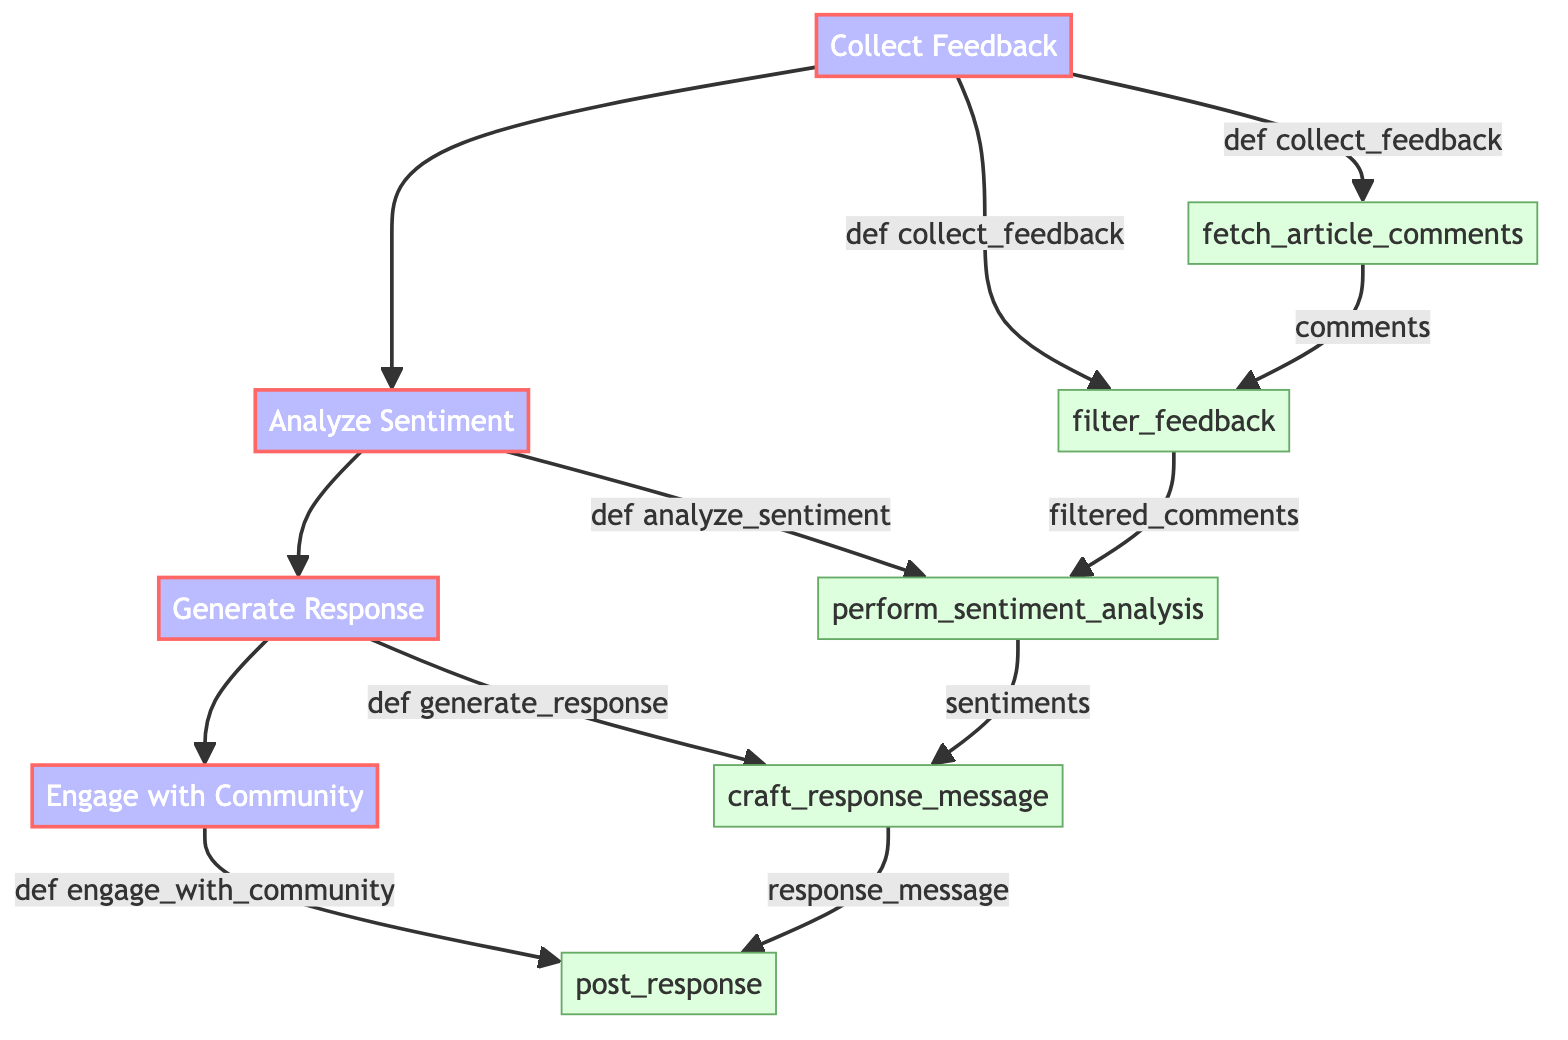What is the first step in the feedback handling process? The first step in the flowchart is "Collect Feedback," which initiates the feedback handling process for business-related news.
Answer: Collect Feedback How many main components are there in the flowchart? The flowchart has four main components: Collect Feedback, Analyze Sentiment, Generate Response, and Engage with Community.
Answer: Four What is the method associated with "Analyze Sentiment"? The method associated with "Analyze Sentiment" is "def analyze_sentiment(filtered_comments):" which initializes the sentiment analysis process mentioned in the diagram.
Answer: def analyze_sentiment(filtered_comments): Which sub-element follows "filter_feedback"? The sub-element that follows "filter_feedback" is "perform_sentiment_analysis," which further processes the filtered feedback.
Answer: perform_sentiment_analysis What action is taken after generating a response? After generating a response, the action taken is to "Engage with Community," which includes posting the response message to the community.
Answer: Engage with Community How does "fetch_article_comments" relate to "filter_feedback"? "fetch_article_comments" provides the initial list of comments which are then passed to "filter_feedback" to remove any irrelevant or inappropriate comments.
Answer: It provides comments for filtering Which platform is included in the "post_response" action? The platforms included in the "post_response" action are news portal, Facebook, Twitter, and Instagram as described in the diagram.
Answer: news portal, Facebook, Twitter, Instagram What type of analysis is performed on the filtered comments? The type of analysis performed on the filtered comments is sentiment analysis to determine the nature of the community feedback.
Answer: Sentiment analysis What is the purpose of "craft_response_message"? The purpose of "craft_response_message" is to create a message that addresses common concerns or positive feedback based on the analyzed sentiments.
Answer: To address concerns or positive feedback 